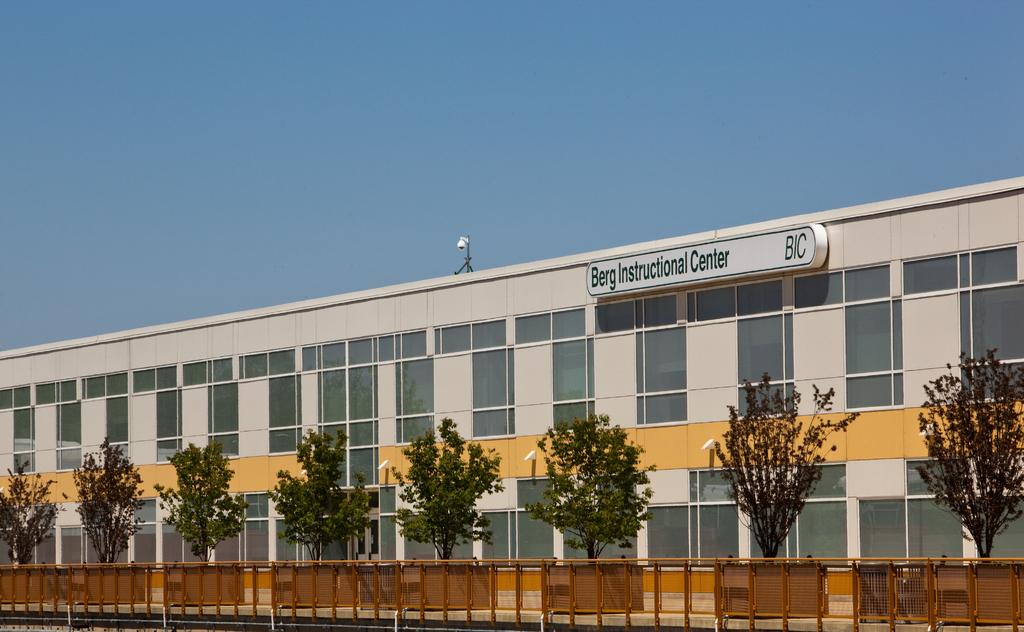What type of structure is present in the image? There is a building in the image. What is written or displayed on the board in the image? There is a board with words in the image. What type of vegetation can be seen in the image? There are trees in the image. What type of barrier is present in the image? There is fencing in the image. What color is the sky in the background of the image? The sky is blue in the background of the image. Can you see a gun being used by someone in the image? There is no gun present in the image. Is there a tub filled with water in the image? There is no tub present in the image. 